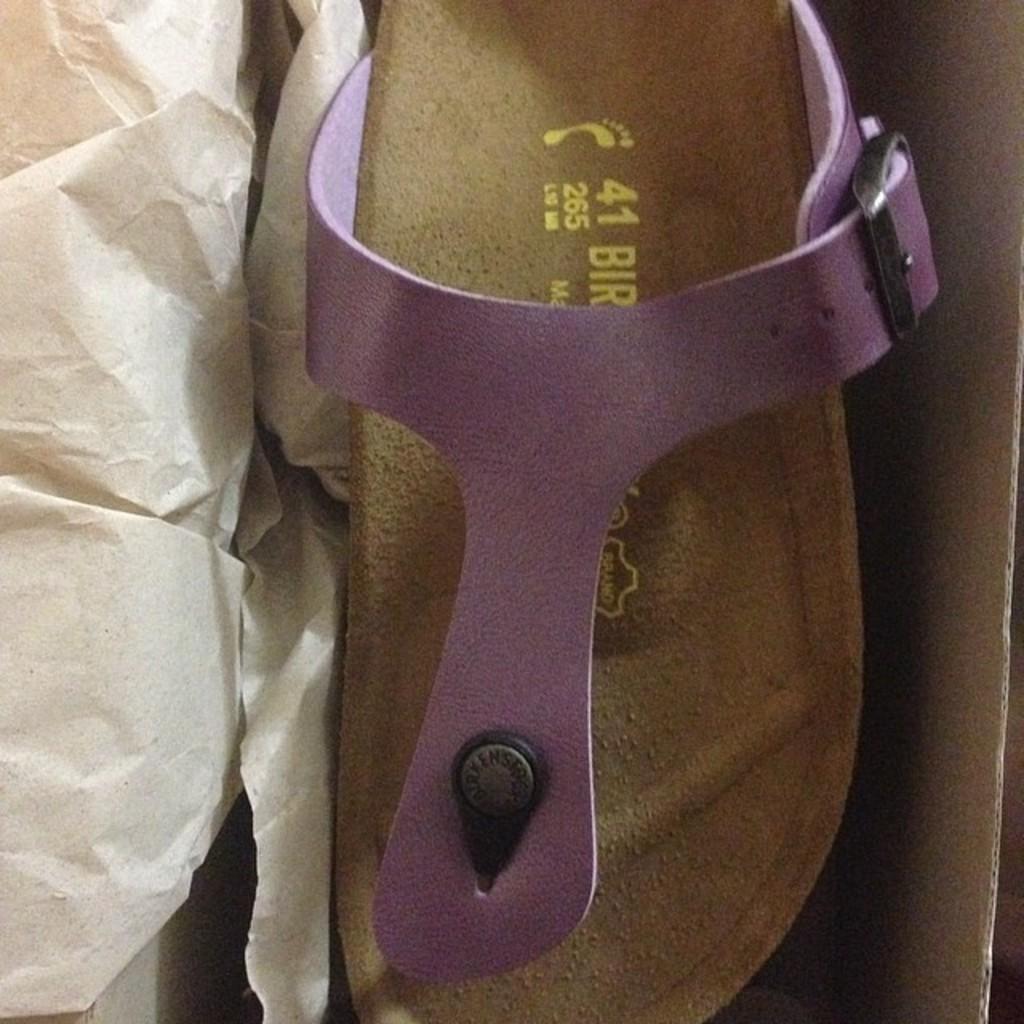How would you summarize this image in a sentence or two? In this image we can see a chappal placed in the carton and there is a paper. 